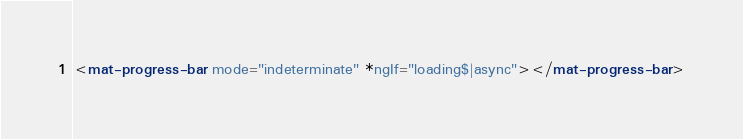Convert code to text. <code><loc_0><loc_0><loc_500><loc_500><_HTML_><mat-progress-bar mode="indeterminate" *ngIf="loading$|async"></mat-progress-bar></code> 